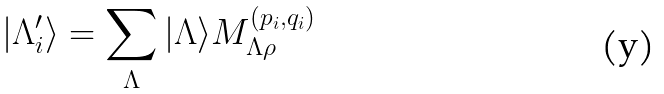<formula> <loc_0><loc_0><loc_500><loc_500>| \Lambda ^ { \prime } _ { i } \rangle = \sum _ { \Lambda } | \Lambda \rangle M ^ { ( p _ { i } , q _ { i } ) } _ { \Lambda \rho }</formula> 